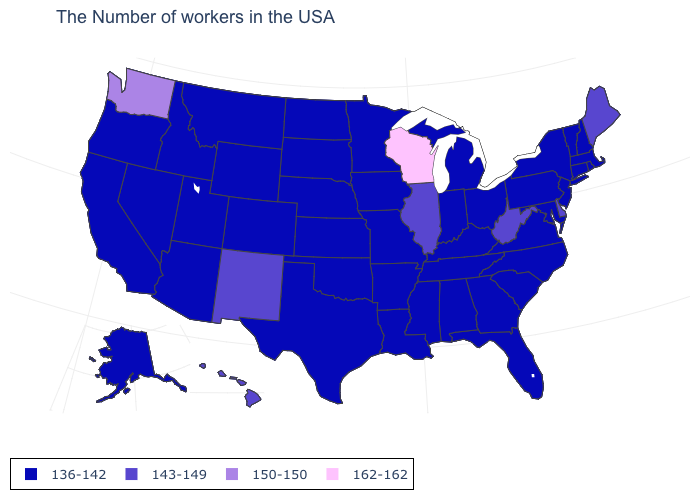What is the value of Oregon?
Concise answer only. 136-142. What is the value of Rhode Island?
Answer briefly. 136-142. Is the legend a continuous bar?
Give a very brief answer. No. Among the states that border Virginia , which have the highest value?
Short answer required. West Virginia. Name the states that have a value in the range 162-162?
Quick response, please. Wisconsin. What is the value of New York?
Quick response, please. 136-142. Name the states that have a value in the range 136-142?
Short answer required. Massachusetts, Rhode Island, New Hampshire, Vermont, Connecticut, New York, New Jersey, Maryland, Pennsylvania, Virginia, North Carolina, South Carolina, Ohio, Florida, Georgia, Michigan, Kentucky, Indiana, Alabama, Tennessee, Mississippi, Louisiana, Missouri, Arkansas, Minnesota, Iowa, Kansas, Nebraska, Oklahoma, Texas, South Dakota, North Dakota, Wyoming, Colorado, Utah, Montana, Arizona, Idaho, Nevada, California, Oregon, Alaska. What is the value of Oklahoma?
Be succinct. 136-142. Name the states that have a value in the range 143-149?
Short answer required. Maine, Delaware, West Virginia, Illinois, New Mexico, Hawaii. What is the highest value in the MidWest ?
Give a very brief answer. 162-162. How many symbols are there in the legend?
Write a very short answer. 4. Is the legend a continuous bar?
Keep it brief. No. Does Arizona have a lower value than Arkansas?
Answer briefly. No. Does New Hampshire have the lowest value in the USA?
Be succinct. Yes. What is the value of Pennsylvania?
Answer briefly. 136-142. 